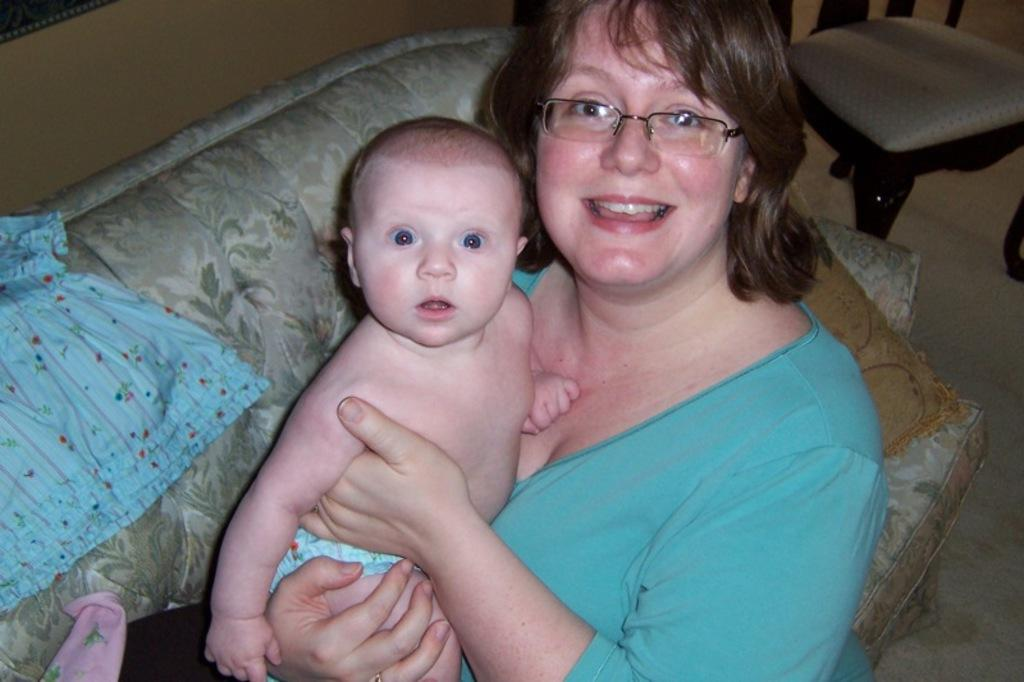Who is the main subject in the foreground of the image? There is a woman in the foreground of the image. What is the woman doing in the image? The woman is carrying a baby in the image. Where are the woman and baby located? The woman and baby are on a couch in the image. What color is the cloth on the couch? There is a blue colored cloth on the couch. What other furniture can be seen in the image? There is a chair in the background of the image. How is the chair positioned in the image? The chair is on the floor in the image. What type of letter is the woman writing to the baby in the image? There is no letter present in the image, and the woman is not writing anything to the baby. Can you see a pail in the image? There is no pail present in the image. 